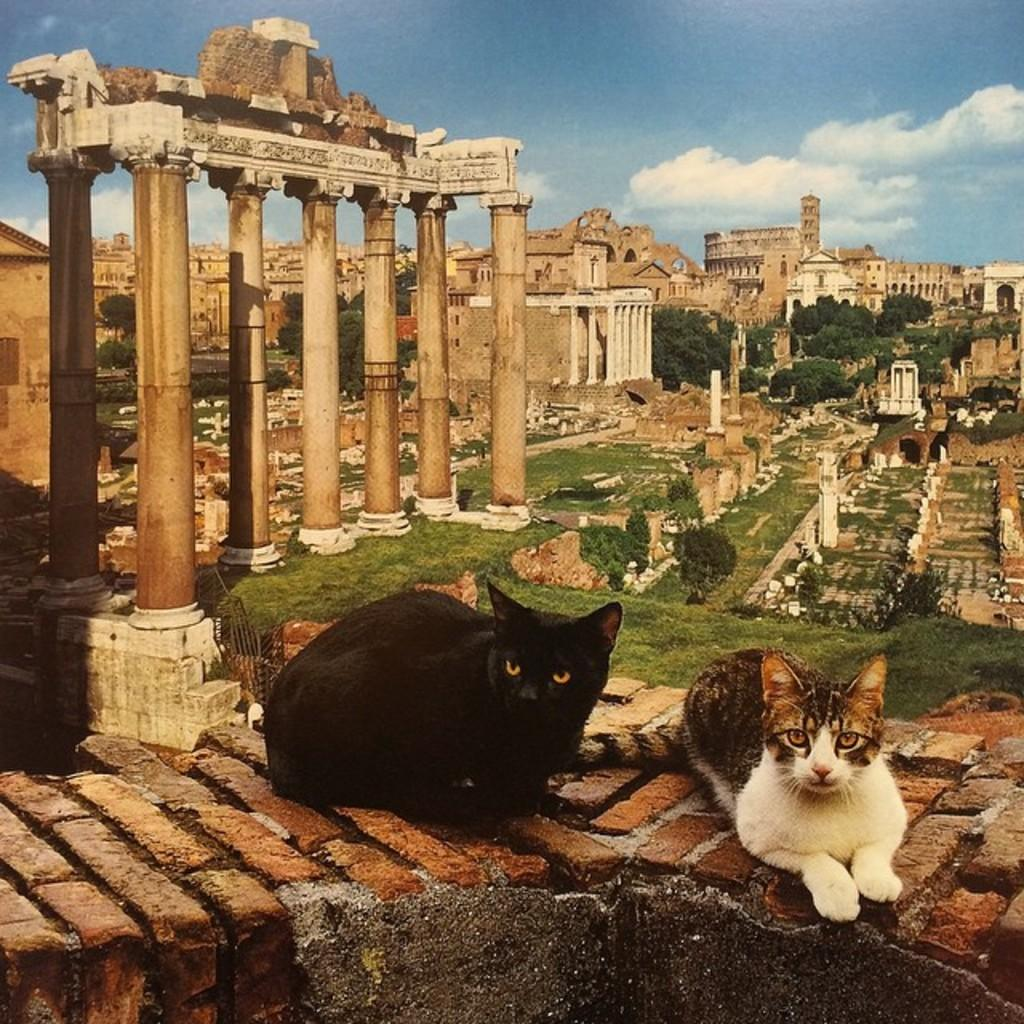What can be seen in the background of the image? The sky is visible in the background of the image. What architectural features are present in the image? There are pillars and castles in the image. What type of vegetation is present in the image? Trees and grass are visible in the image. Are there any animals present in the image? Yes, there are cats on the wall at the bottom portion of the image. What type of reward can be seen hanging from the trees in the image? There are no rewards hanging from the trees in the image; only trees and grass are present. What type of rabbits can be seen hiding in the grass in the image? There are no rabbits present in the image; only cats on the wall and other elements mentioned in the facts are visible. 